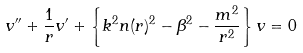<formula> <loc_0><loc_0><loc_500><loc_500>v ^ { \prime \prime } + \frac { 1 } { r } v ^ { \prime } + \left \{ k ^ { 2 } n ( r ) ^ { 2 } - \beta ^ { 2 } - \frac { m ^ { 2 } } { r ^ { 2 } } \right \} v = 0</formula> 